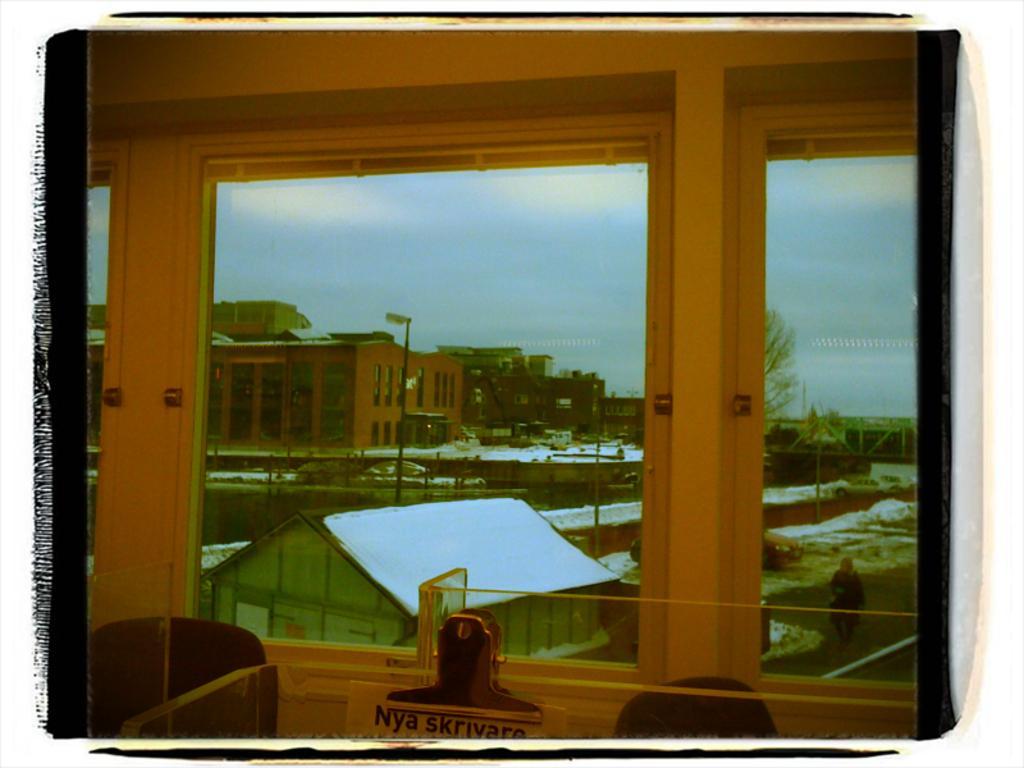Could you give a brief overview of what you see in this image? In this image I can see a glass window. Back Side I can see buildings,light-pole,trees and a vehicles on the road. The sky is in blue and white color. 